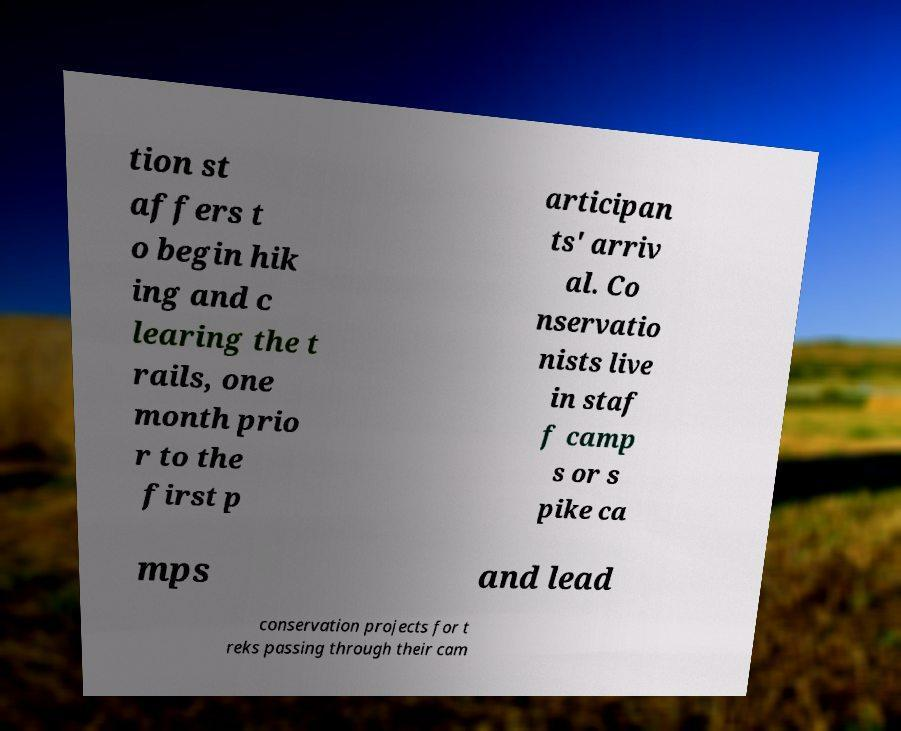Can you read and provide the text displayed in the image?This photo seems to have some interesting text. Can you extract and type it out for me? tion st affers t o begin hik ing and c learing the t rails, one month prio r to the first p articipan ts' arriv al. Co nservatio nists live in staf f camp s or s pike ca mps and lead conservation projects for t reks passing through their cam 